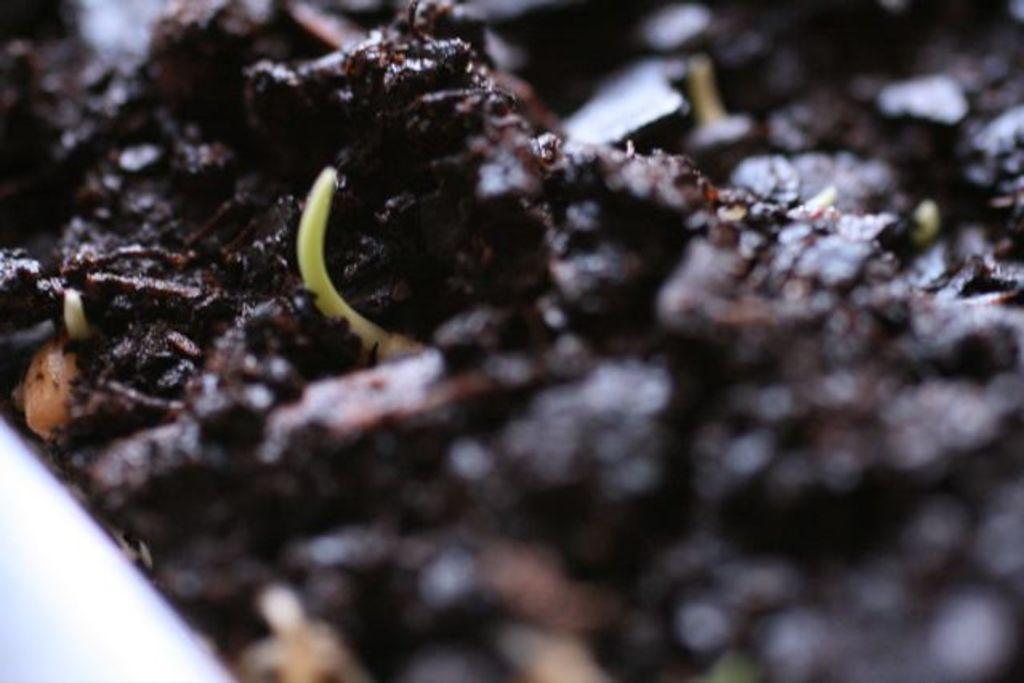Describe this image in one or two sentences. This image contains some garbage. 